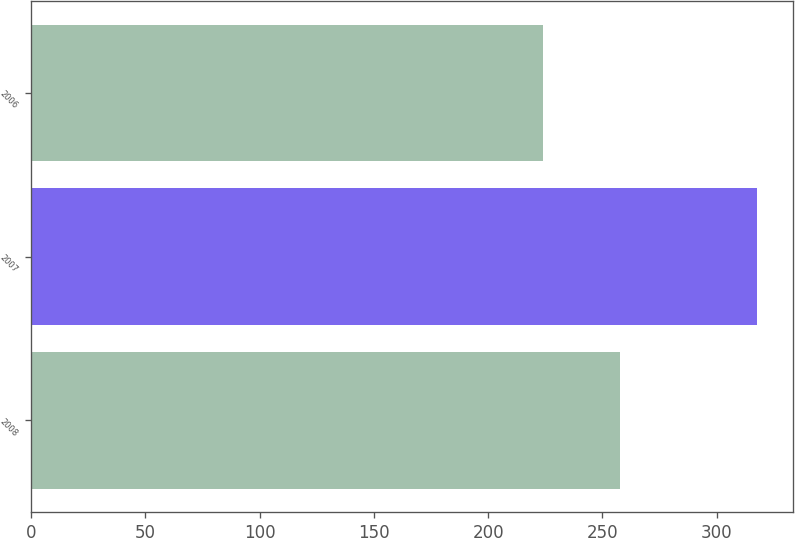Convert chart to OTSL. <chart><loc_0><loc_0><loc_500><loc_500><bar_chart><fcel>2008<fcel>2007<fcel>2006<nl><fcel>257.8<fcel>317.4<fcel>223.8<nl></chart> 